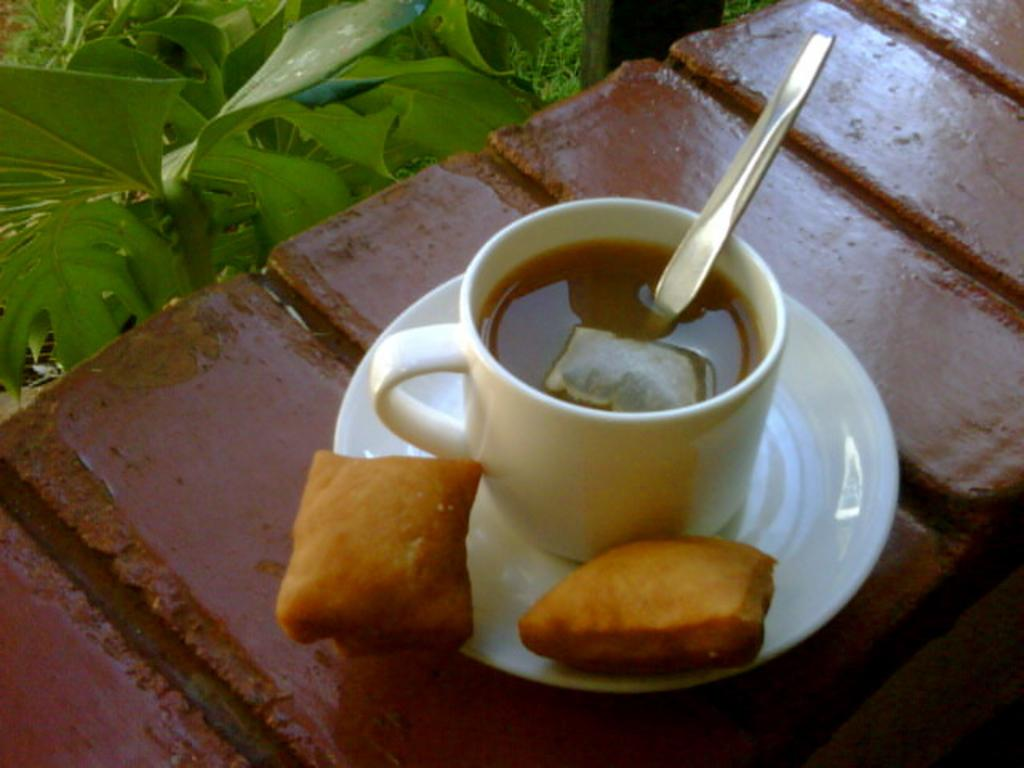What type of dishware is present in the image? There is a white color saucer and a white color tea cup in the image. What is placed inside the tea cup? There is a spoon kept in the tea cup. What other object can be seen in the image? There is a green color plant in the image. How many women are walking in the direction of the yak in the image? There are no women or yaks present in the image. 